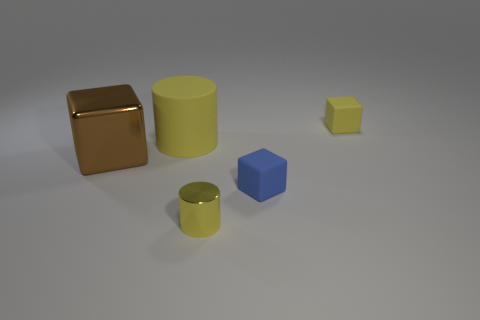Do the cube behind the large yellow thing and the yellow cylinder that is in front of the brown metal object have the same material?
Provide a succinct answer. No. There is a yellow cube that is the same size as the yellow metallic cylinder; what is its material?
Offer a terse response. Rubber. There is a cylinder behind the tiny cylinder; does it have the same color as the cylinder to the right of the large cylinder?
Provide a succinct answer. Yes. Is the material of the tiny cube behind the large yellow rubber cylinder the same as the large brown cube?
Offer a very short reply. No. What material is the big thing that is the same shape as the tiny shiny thing?
Your answer should be very brief. Rubber. What shape is the small thing that is made of the same material as the blue cube?
Give a very brief answer. Cube. Are there more matte objects that are behind the brown metallic object than yellow shiny objects?
Provide a succinct answer. Yes. What number of other cylinders are the same color as the tiny shiny cylinder?
Your answer should be very brief. 1. What number of other objects are the same color as the large matte cylinder?
Your answer should be very brief. 2. Is the number of tiny yellow cylinders greater than the number of big gray cylinders?
Provide a short and direct response. Yes. 